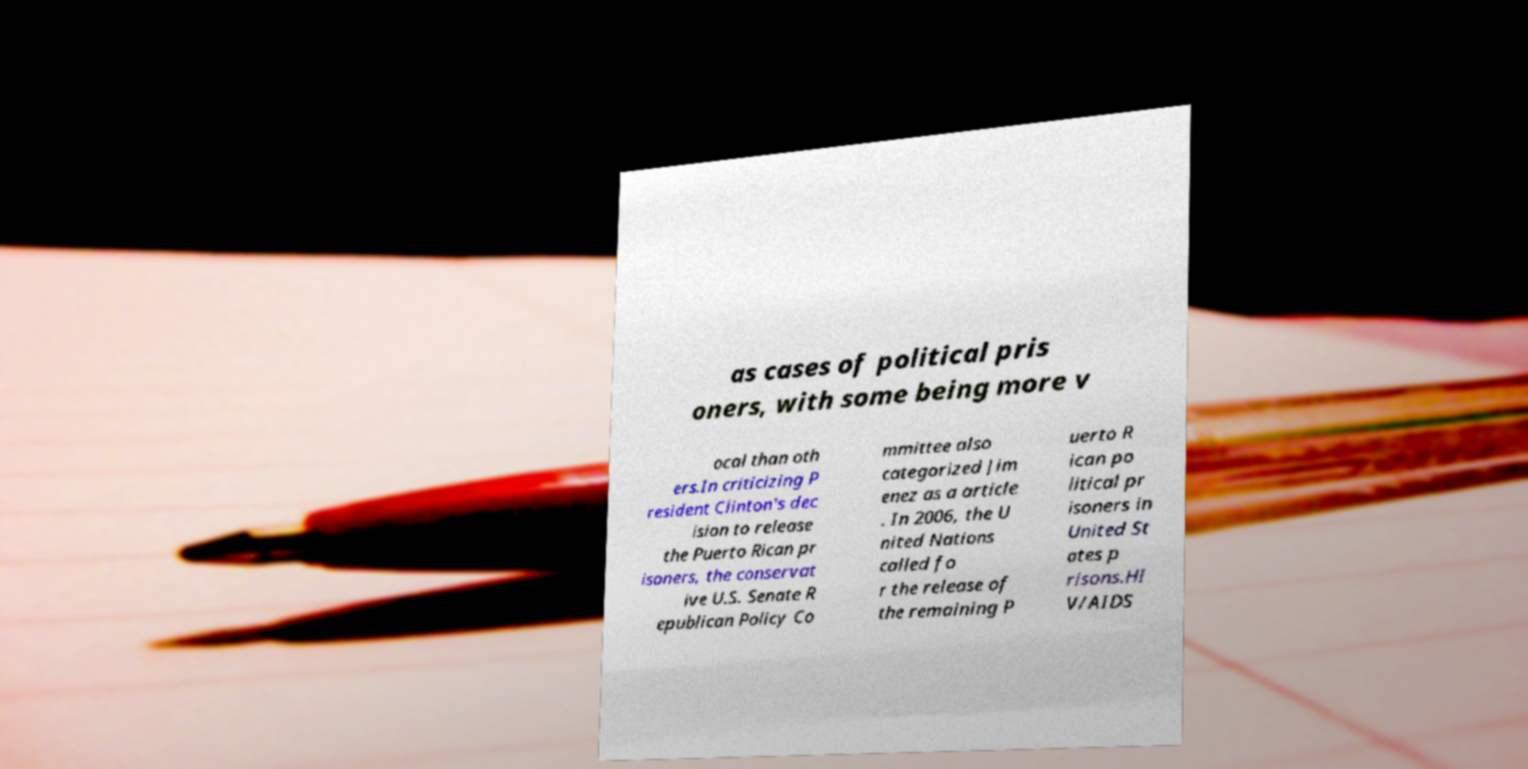I need the written content from this picture converted into text. Can you do that? as cases of political pris oners, with some being more v ocal than oth ers.In criticizing P resident Clinton's dec ision to release the Puerto Rican pr isoners, the conservat ive U.S. Senate R epublican Policy Co mmittee also categorized Jim enez as a article . In 2006, the U nited Nations called fo r the release of the remaining P uerto R ican po litical pr isoners in United St ates p risons.HI V/AIDS 